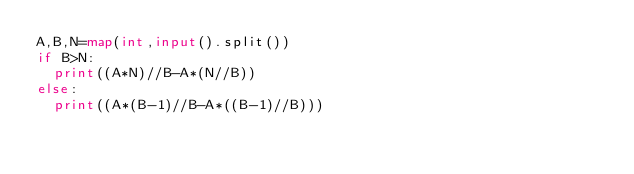Convert code to text. <code><loc_0><loc_0><loc_500><loc_500><_Python_>A,B,N=map(int,input().split())
if B>N:
  print((A*N)//B-A*(N//B))
else:
  print((A*(B-1)//B-A*((B-1)//B)))</code> 